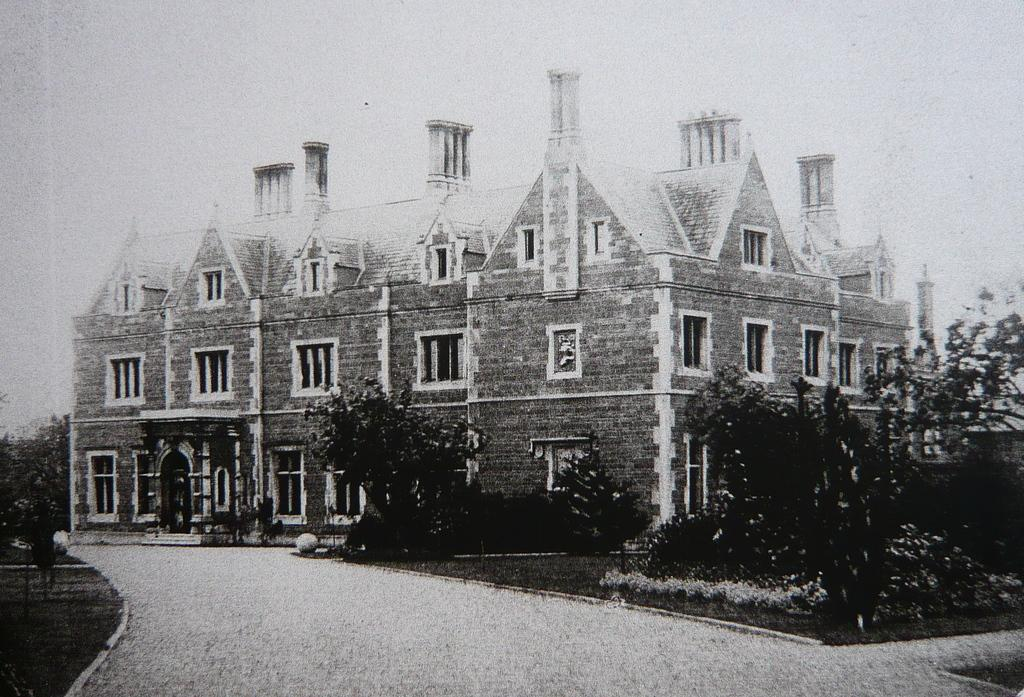What is the color scheme of the image? The image is black and white. What is the main subject of the image? There is a building in the image. What are the main features of the building? The building has walls, windows, and roofs. What is located in front of the building? There are trees, plants, and a road in front of the building. How many cows can be seen grazing on the dirt in front of the building? There are no cows or dirt present in the image; it features a black and white building with trees, plants, and a road in front of it. 